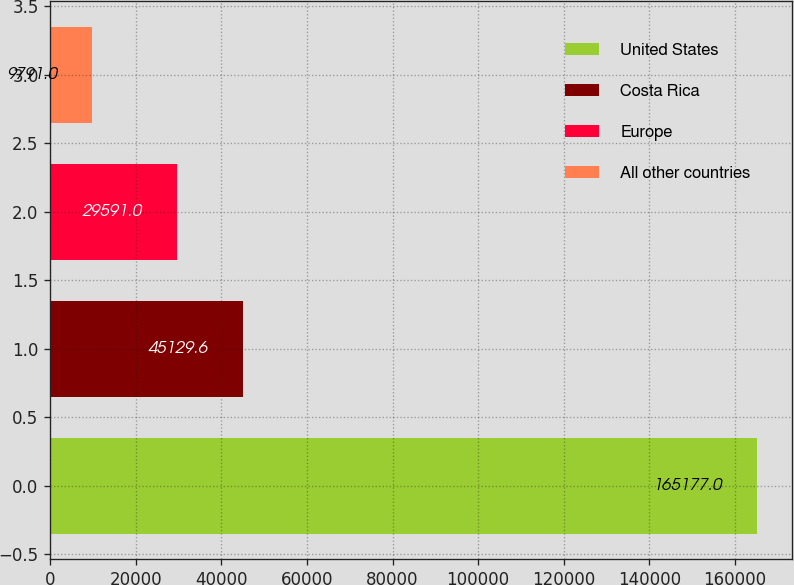<chart> <loc_0><loc_0><loc_500><loc_500><bar_chart><fcel>United States<fcel>Costa Rica<fcel>Europe<fcel>All other countries<nl><fcel>165177<fcel>45129.6<fcel>29591<fcel>9791<nl></chart> 